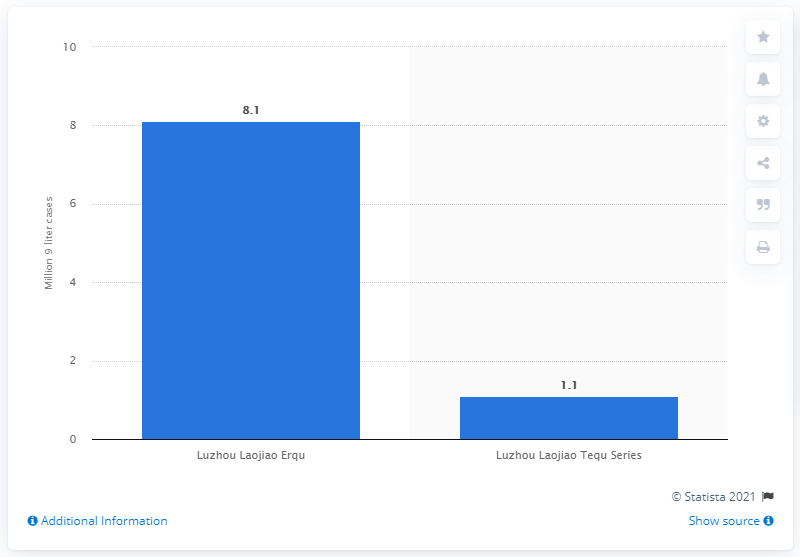Draw attention to some important aspects in this diagram. Luzhou Laojiao was the leading baijiu brand worldwide in 2013. 